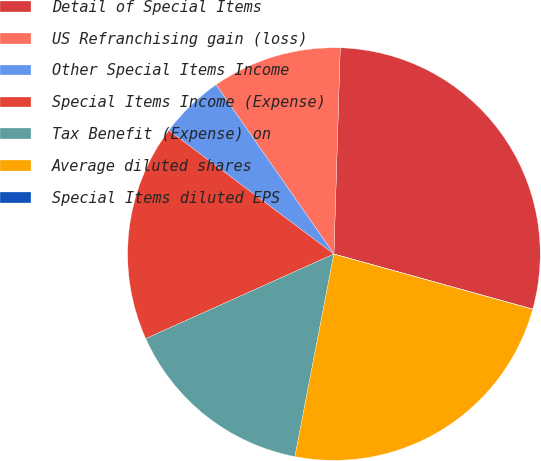<chart> <loc_0><loc_0><loc_500><loc_500><pie_chart><fcel>Detail of Special Items<fcel>US Refranchising gain (loss)<fcel>Other Special Items Income<fcel>Special Items Income (Expense)<fcel>Tax Benefit (Expense) on<fcel>Average diluted shares<fcel>Special Items diluted EPS<nl><fcel>28.81%<fcel>10.17%<fcel>5.09%<fcel>16.95%<fcel>15.25%<fcel>23.72%<fcel>0.01%<nl></chart> 